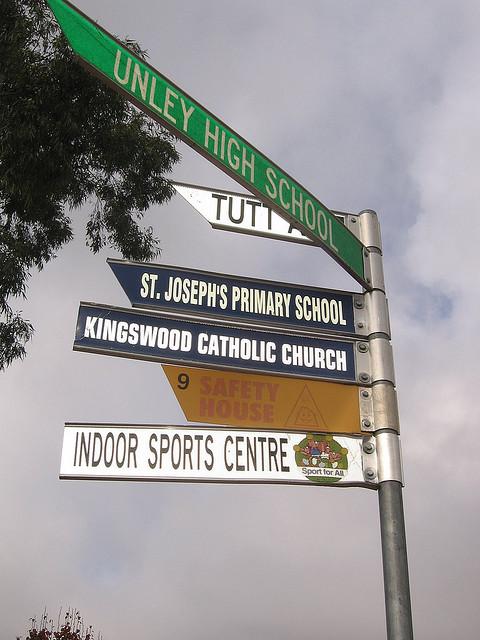How many signs are there?
Be succinct. 6. What schools are nearby?
Write a very short answer. Public, private. What is in the top left of the screen?
Answer briefly. Tree. 